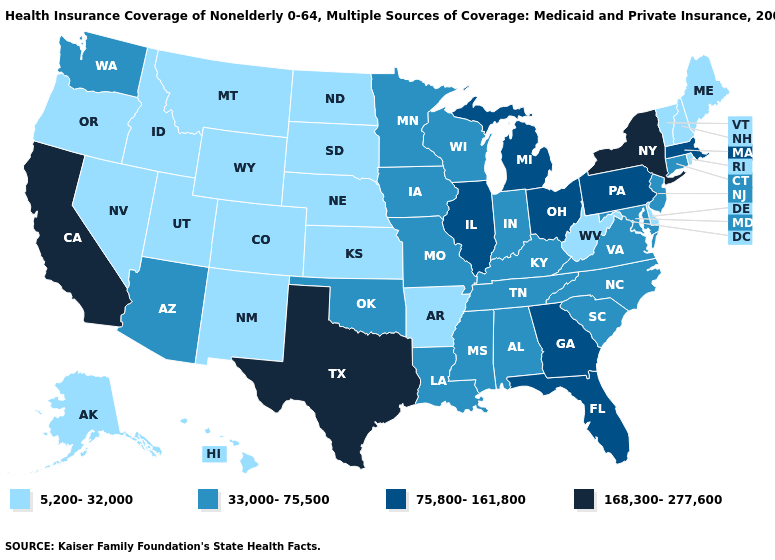Among the states that border New Jersey , does Delaware have the lowest value?
Quick response, please. Yes. Among the states that border New York , does Vermont have the highest value?
Concise answer only. No. What is the value of Oklahoma?
Write a very short answer. 33,000-75,500. Does the first symbol in the legend represent the smallest category?
Answer briefly. Yes. What is the value of Texas?
Be succinct. 168,300-277,600. Name the states that have a value in the range 33,000-75,500?
Write a very short answer. Alabama, Arizona, Connecticut, Indiana, Iowa, Kentucky, Louisiana, Maryland, Minnesota, Mississippi, Missouri, New Jersey, North Carolina, Oklahoma, South Carolina, Tennessee, Virginia, Washington, Wisconsin. Does Iowa have the lowest value in the USA?
Give a very brief answer. No. Among the states that border Kansas , which have the highest value?
Quick response, please. Missouri, Oklahoma. Name the states that have a value in the range 5,200-32,000?
Short answer required. Alaska, Arkansas, Colorado, Delaware, Hawaii, Idaho, Kansas, Maine, Montana, Nebraska, Nevada, New Hampshire, New Mexico, North Dakota, Oregon, Rhode Island, South Dakota, Utah, Vermont, West Virginia, Wyoming. What is the value of New Hampshire?
Answer briefly. 5,200-32,000. What is the value of Louisiana?
Keep it brief. 33,000-75,500. Name the states that have a value in the range 33,000-75,500?
Keep it brief. Alabama, Arizona, Connecticut, Indiana, Iowa, Kentucky, Louisiana, Maryland, Minnesota, Mississippi, Missouri, New Jersey, North Carolina, Oklahoma, South Carolina, Tennessee, Virginia, Washington, Wisconsin. Does Alaska have a higher value than Maine?
Give a very brief answer. No. Name the states that have a value in the range 75,800-161,800?
Give a very brief answer. Florida, Georgia, Illinois, Massachusetts, Michigan, Ohio, Pennsylvania. Name the states that have a value in the range 75,800-161,800?
Give a very brief answer. Florida, Georgia, Illinois, Massachusetts, Michigan, Ohio, Pennsylvania. 